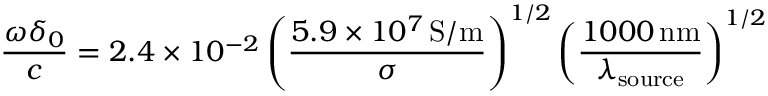Convert formula to latex. <formula><loc_0><loc_0><loc_500><loc_500>\frac { \omega \delta _ { 0 } } { c } = 2 . 4 \times 1 0 ^ { - 2 } \left ( \frac { 5 . 9 \times 1 0 ^ { 7 } \, S / m } { \sigma } \right ) ^ { 1 / 2 } \left ( \frac { 1 0 0 0 \, n m } { \lambda _ { s o u r c e } } \right ) ^ { 1 / 2 } \,</formula> 